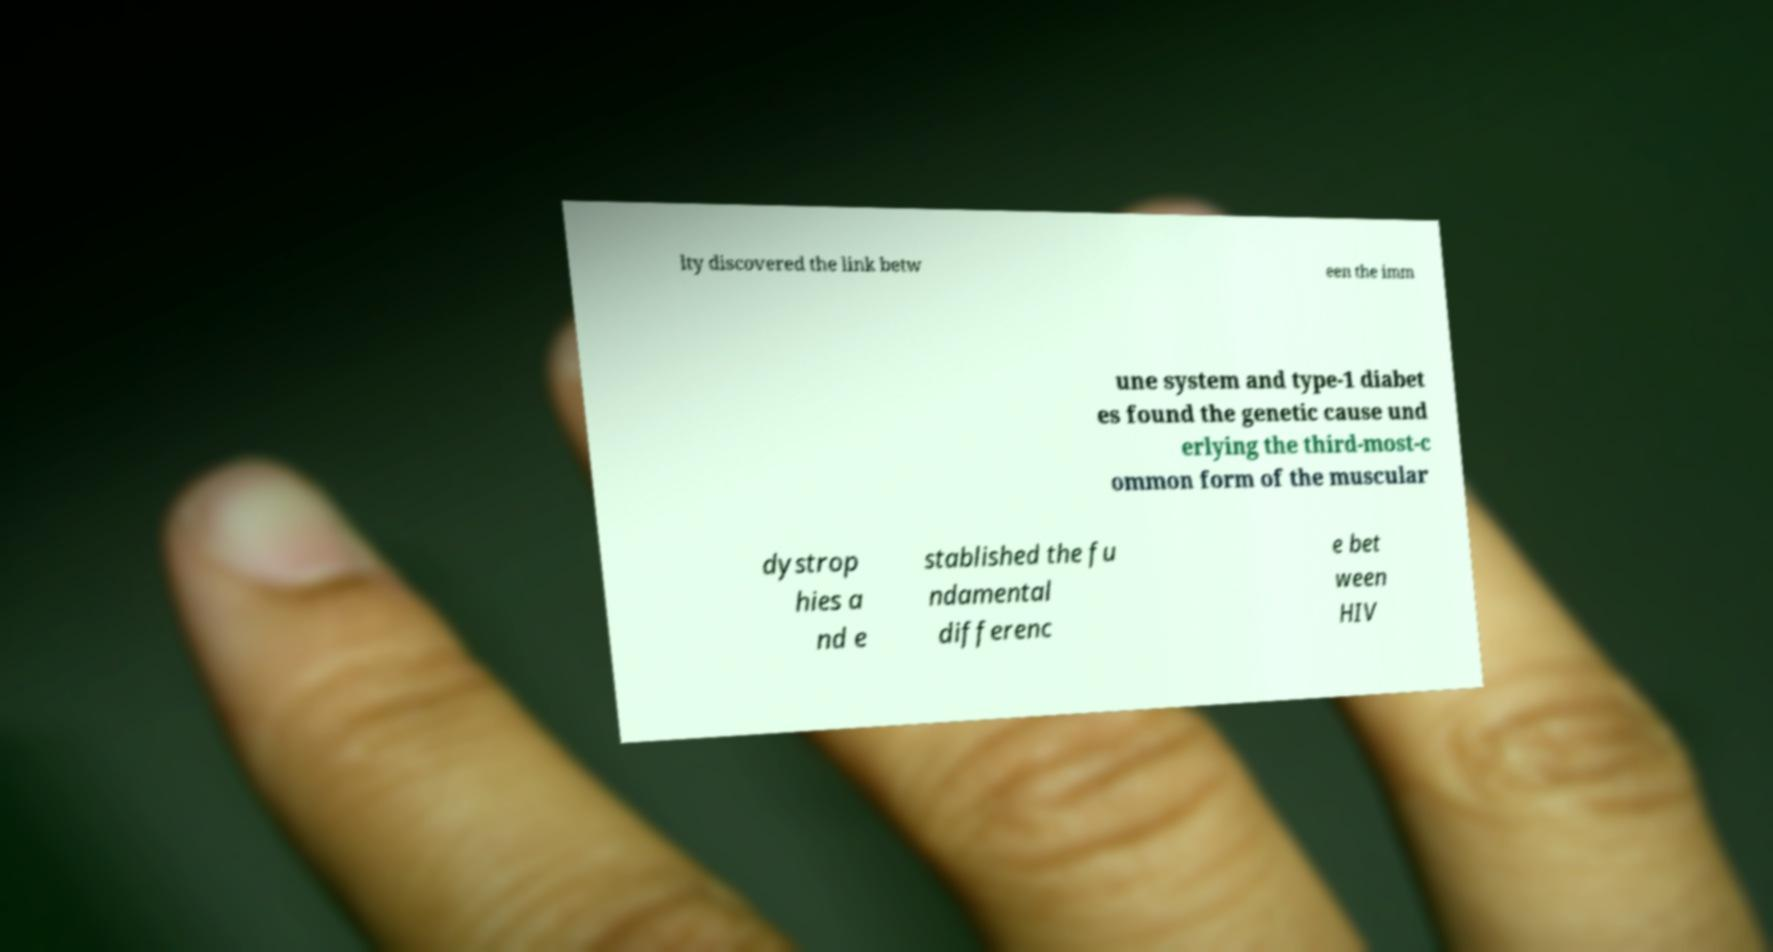Could you assist in decoding the text presented in this image and type it out clearly? lty discovered the link betw een the imm une system and type-1 diabet es found the genetic cause und erlying the third-most-c ommon form of the muscular dystrop hies a nd e stablished the fu ndamental differenc e bet ween HIV 